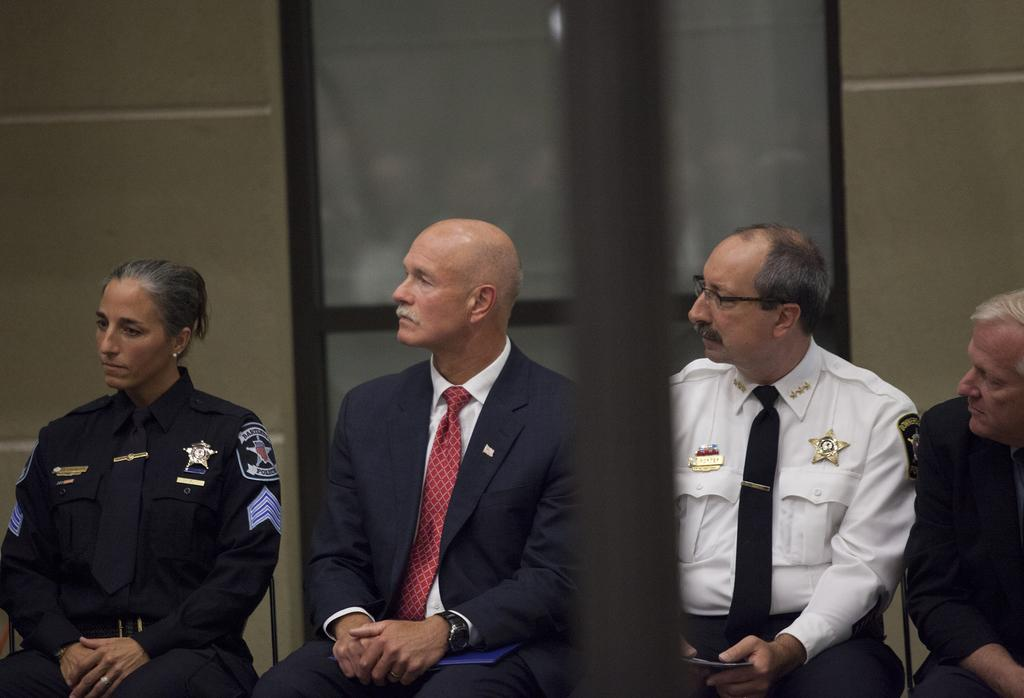What are the people in the image doing? There is a group of people sitting on chairs in the image. What can be seen in the background of the image? There appears to be a door in the background of the image. What is visible on one side of the image? There is a wall visible in the image. What is located in the foreground of the image? There is a pole in the foreground of the image. Can you see a bee buzzing around the people in the image? There is no bee present in the image. Is there a hose attached to the pole in the foreground of the image? There is no hose visible in the image. 